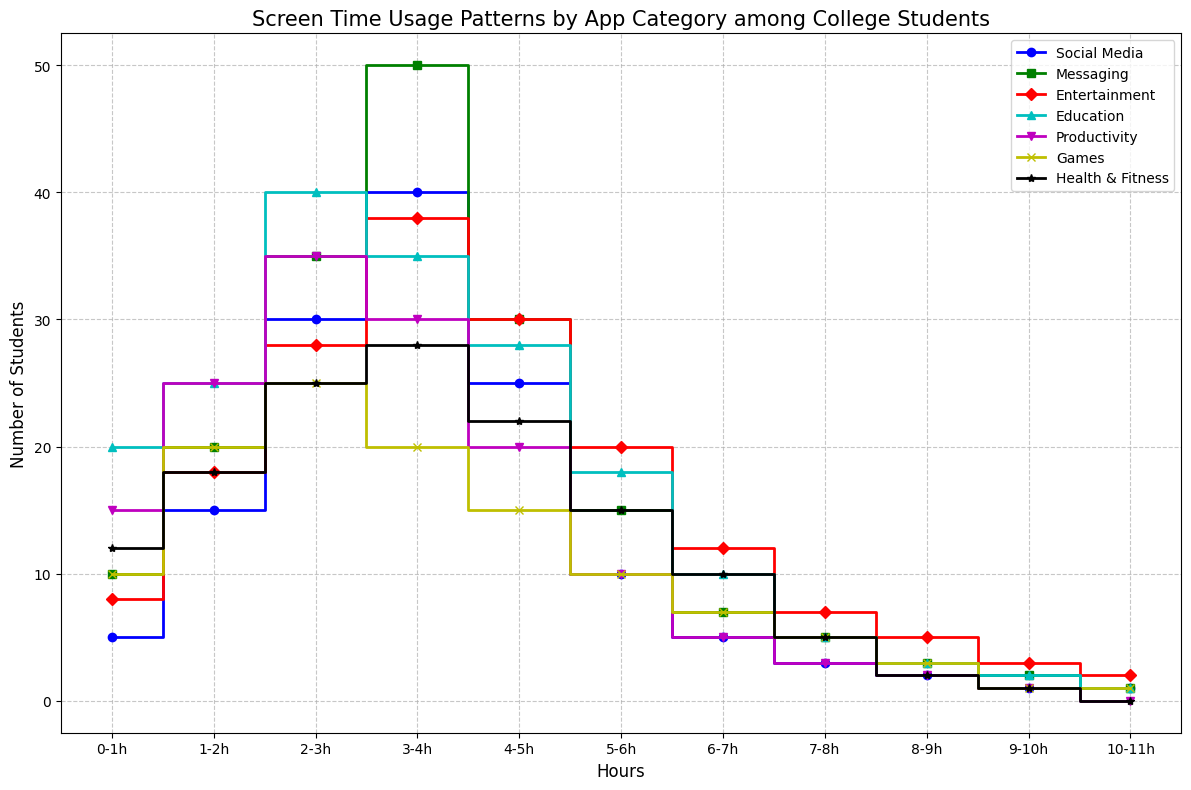What app category sees the highest number of students using it for 2-3 hours? To determine which app category sees the highest number of students using it for 2-3 hours, we look at the y-values corresponding to the 2-3h mark. Social Media has 30, Messaging has 35, Entertainment has 28, Education has 40, Productivity has 35, Games have 25, and Health & Fitness has 25. The highest number is 40 in the Education category.
Answer: Education Which app category has the least number of students using it for 10-11 hours? To find the app category with the least number of students using it for 10-11 hours, we compare the y-values at the 10-11h mark. Social Media, Entertainment, and Games have 1 student each, Productivity and Health & Fitness have 0 students, Messaging has 1, and Education has 1. Since 0 is the minimum, Productivity and Health & Fitness are the categories with the least number of students using it for 10-11 hours.
Answer: Productivity and Health & Fitness For which app category do the number of students peak the earliest? We need to determine the app category where student usage peaks at the earliest time interval. For Social Media, the highest y-value (40) is at the 3-4h mark; for Messaging (50) at the 3-4h mark; for Entertainment (38) at the 3-4h mark; for Education (40) at the 2-3h mark; for Productivity (35) at the 2-3h mark; for Games (25) at the 2-3h mark; for Health & Fitness (28) at the 3-4h mark. The earliest peak is at the 2-3h mark for Education, Productivity, and Games.
Answer: Education, Productivity, and Games How many more students use Messaging for 5-6 hours compared to Games? To find the difference in the number of students using Messaging and Games for 5-6 hours, we subtract the y-value for Games from the y-value for Messaging at the 5-6h mark. Messaging has 15, and Games have 10, the difference being 15 - 10 = 5.
Answer: 5 Which app category experiences a steady decline without any increase in the number of students from 0 to 11 hours? We check each app category for a consistent decrease in the number of students without any increase. Social Media, Messaging, Education, Health & Fitness, and Games show fluctuations; however, Productivity shows a steady decline: from 25 (1-2h) to 0 (10-11h) without any increase.
Answer: Productivity Which app categories see a drop in usage between 7-8 hours and 9-10 hours? We look for a decrease in y-values from 7-8h to 9-10h mark. For Social Media, usage drops from 3 to 1; for Messaging, from 5 to 2; for Entertainment, from 7 to 3; for Education from 5 to 2; for Productivity, from 3 to 1; for Games, from 5 to 1; and for Health & Fitness, from 5 to 1. All categories see a drop.
Answer: All Which app category has the highest minimum screen time usage across different hours? By identifying the minimum y-value for each category and comparing them, we have: Social Media (1), Messaging (1), Entertainment (2), Education (1), Productivity (0), Games (1), Health & Fitness (0). Entertainment has the highest minimum of 2.
Answer: Entertainment 